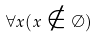<formula> <loc_0><loc_0><loc_500><loc_500>\forall x ( x \notin \emptyset )</formula> 